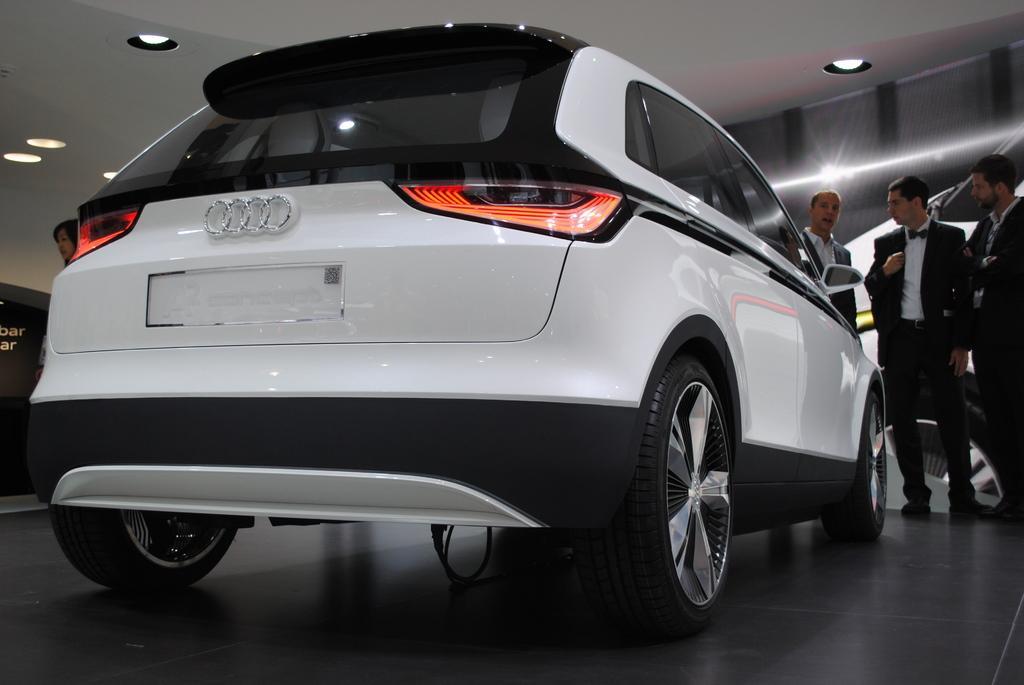Describe this image in one or two sentences. In this image, I can see a car, which is black and white in color. This is the logo of an audi car company, which is attached to the car. There are three men standing. This looks like a poster, which is attached to the wall. These are the ceiling lights, which are attached to the roof. I can see a woman beside the car. 